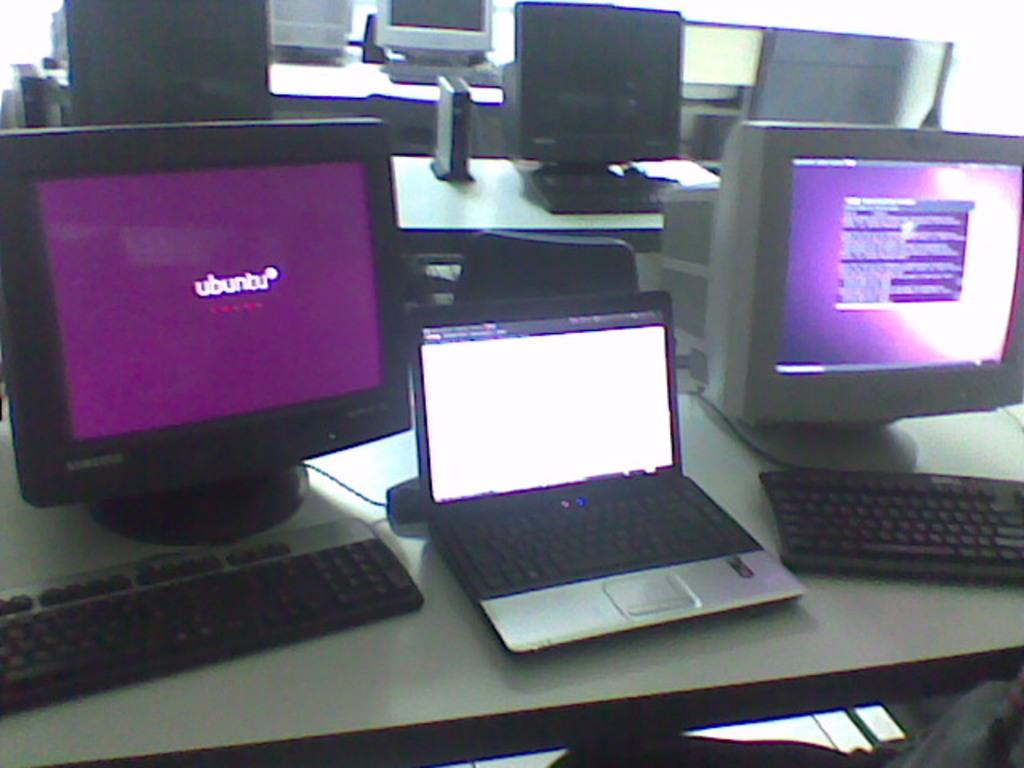<image>
Share a concise interpretation of the image provided. tables holding laptops, keyboards, and monitors one of which has purple ubuntu screen 